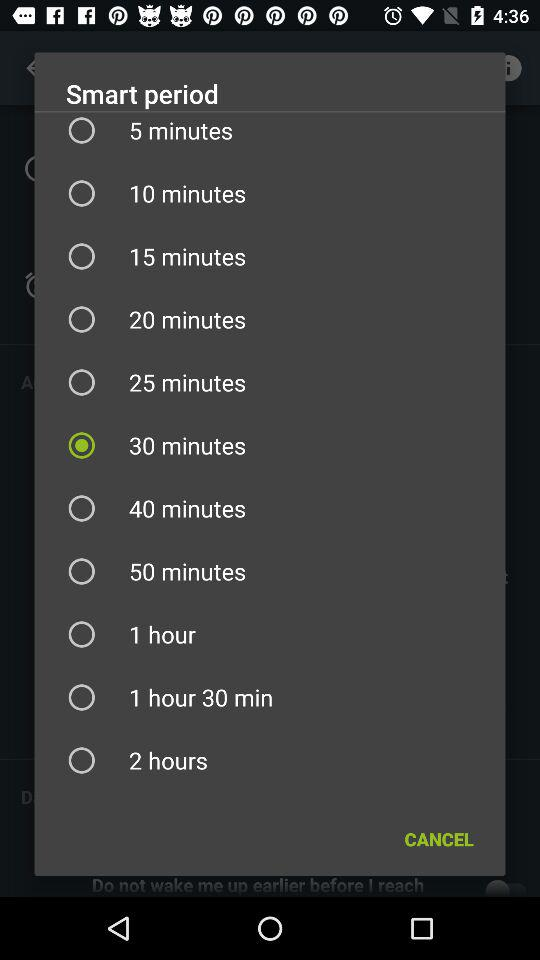What's the selected "Smart period"? The selected "Smart period" is 30 minutes. 